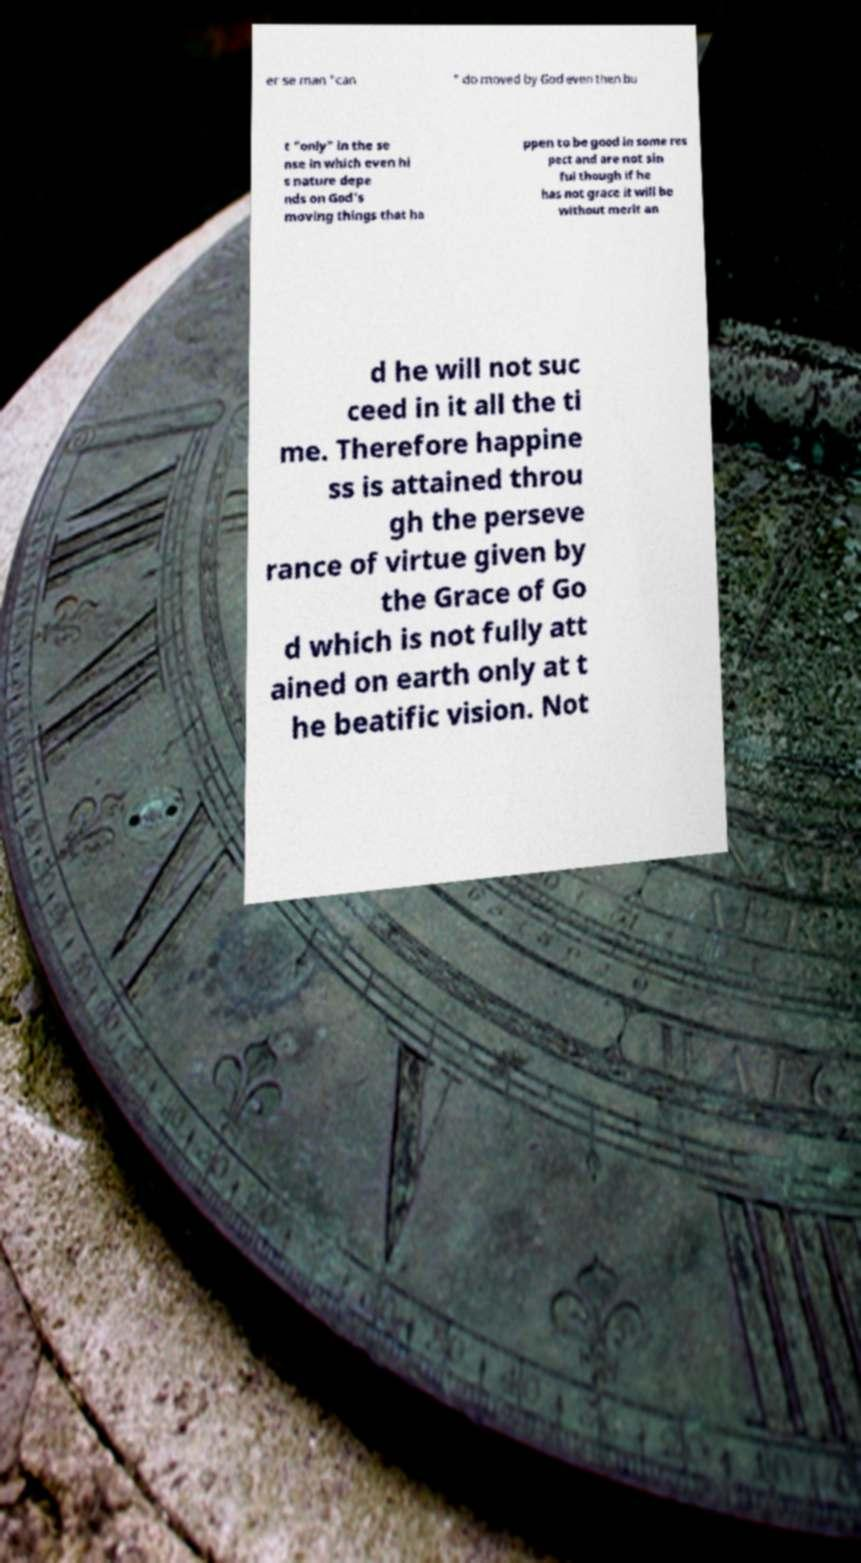Please read and relay the text visible in this image. What does it say? er se man "can " do moved by God even then bu t "only" in the se nse in which even hi s nature depe nds on God's moving things that ha ppen to be good in some res pect and are not sin ful though if he has not grace it will be without merit an d he will not suc ceed in it all the ti me. Therefore happine ss is attained throu gh the perseve rance of virtue given by the Grace of Go d which is not fully att ained on earth only at t he beatific vision. Not 